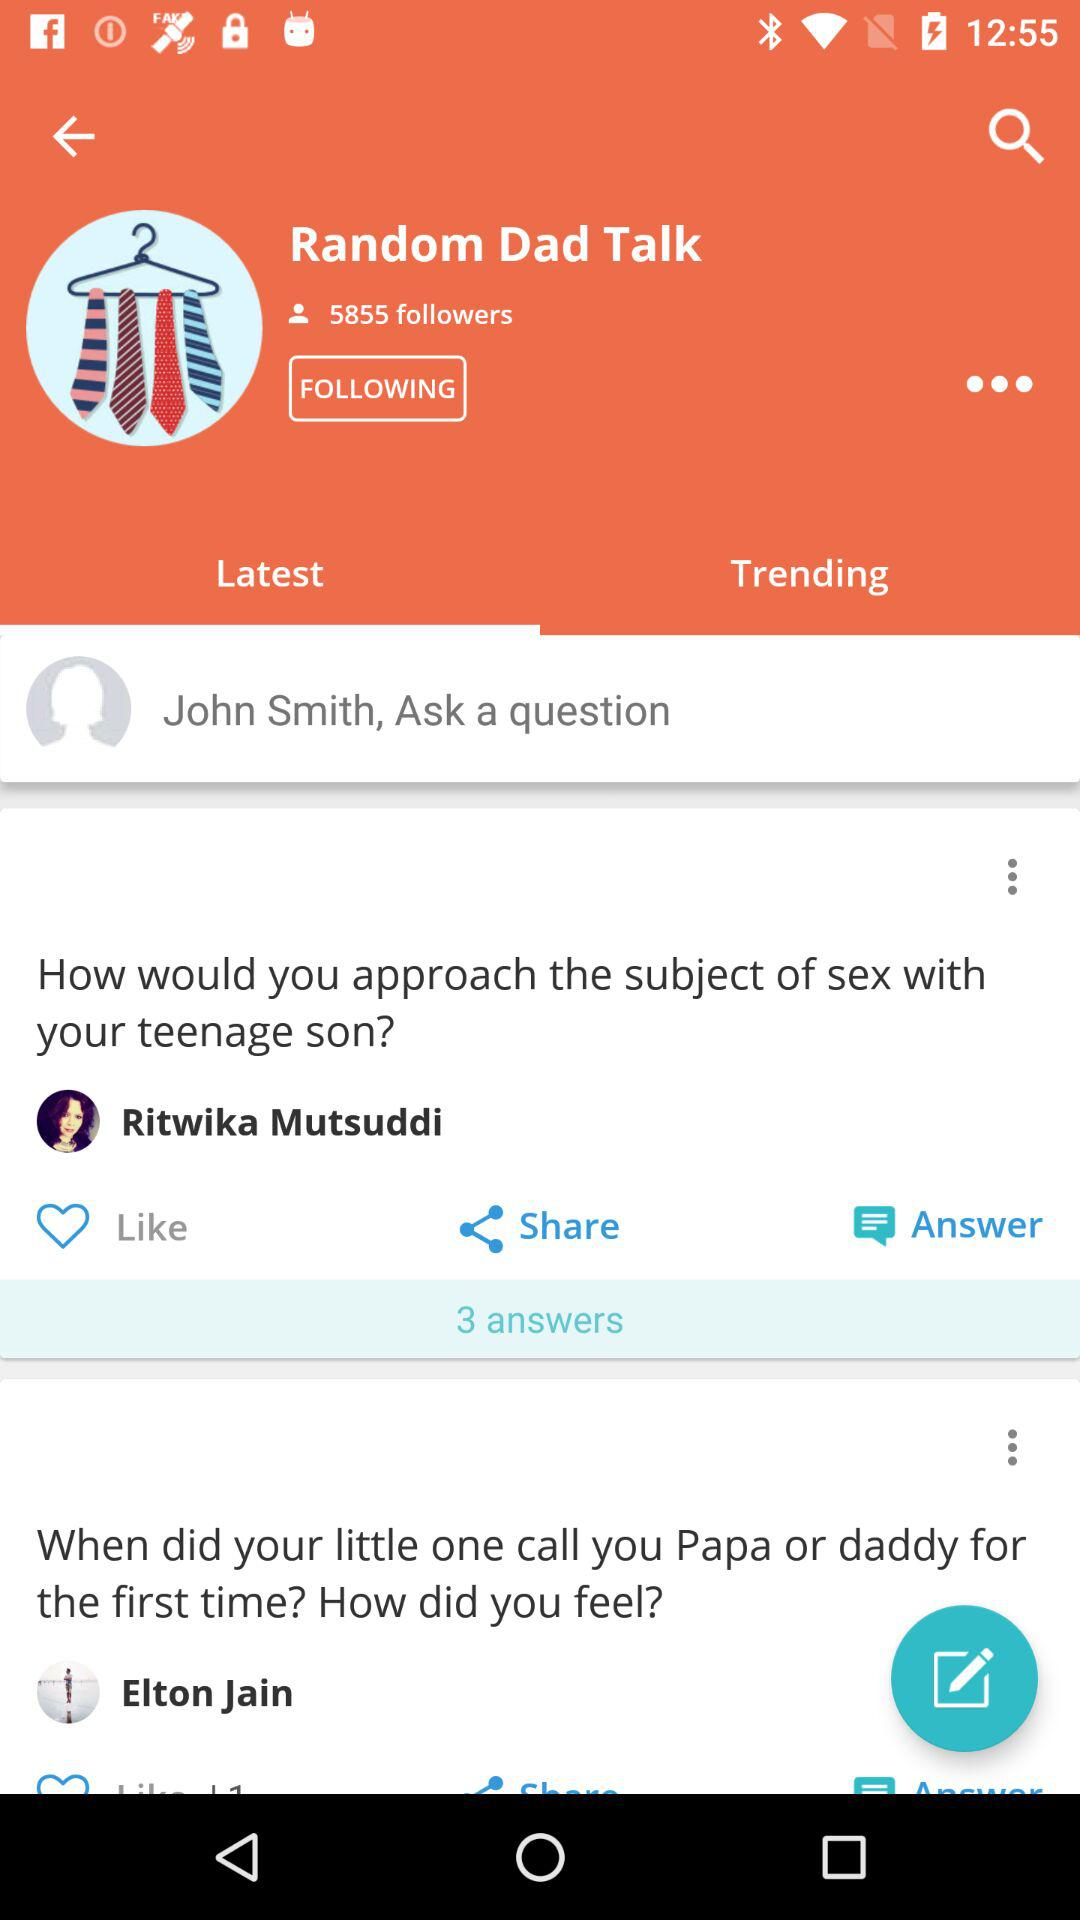What is the profile name? The profile names are "John Smith", "Ritwika Mutsuddi" and "Elton Jain". 